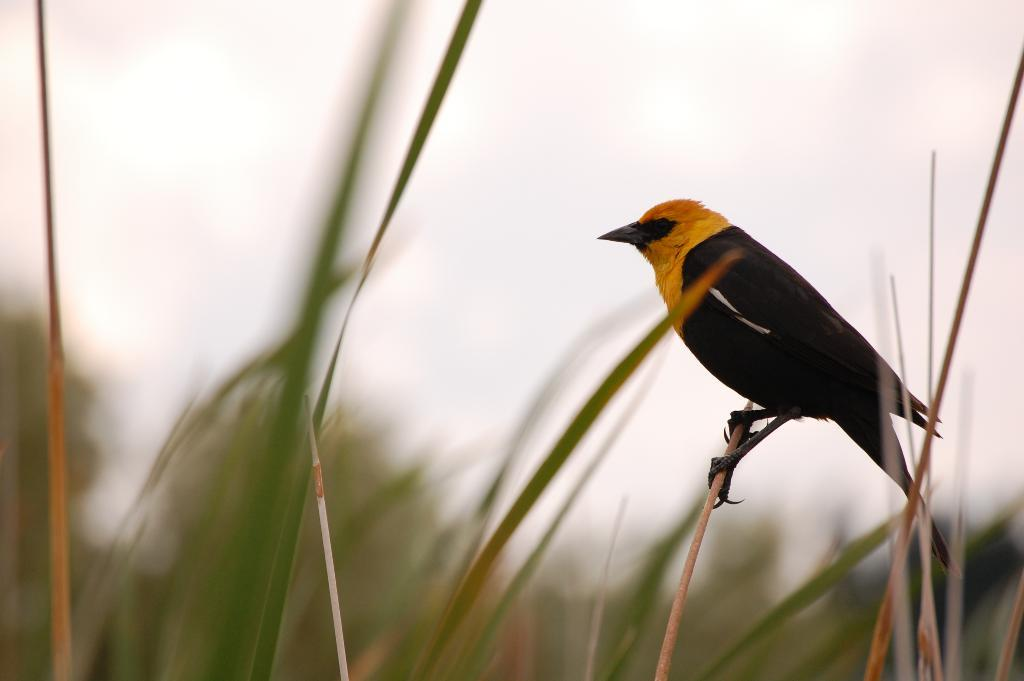What type of animal is in the picture? There is a bird in the picture. What color are the bird's feathers? The bird has black feathers. What type of vegetation is in the picture? There is grass in the picture. What is visible in the background of the picture? The sky is clear in the background. How many hands are visible in the picture? There are no hands visible in the picture; it features a bird and grass. Can you describe the frogs' behavior in the picture? There are no frogs present in the picture; it features a bird and grass. 